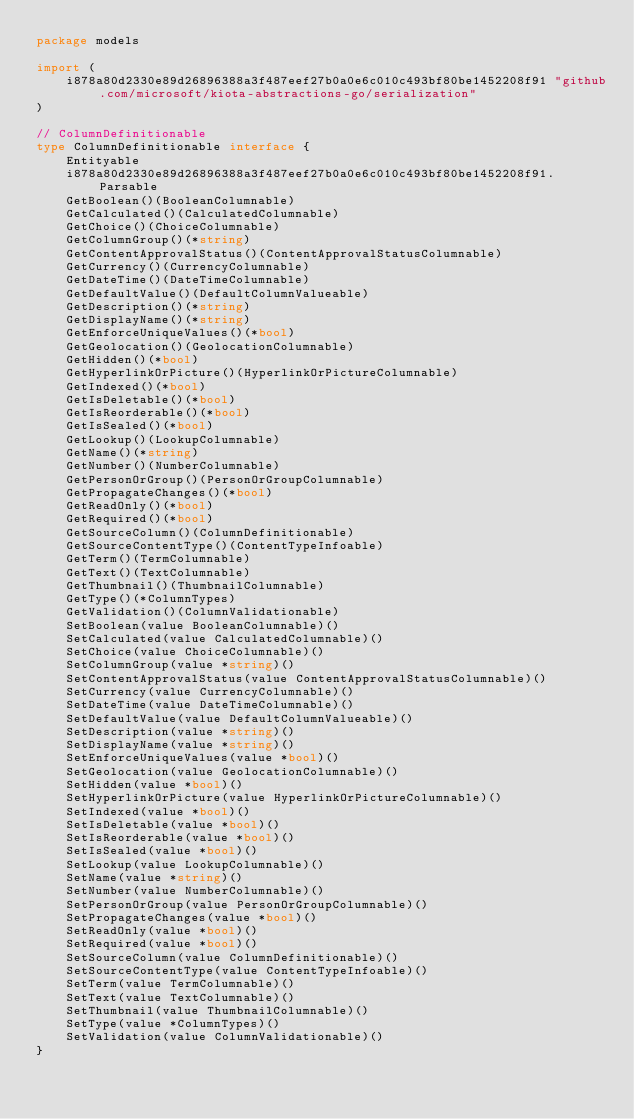Convert code to text. <code><loc_0><loc_0><loc_500><loc_500><_Go_>package models

import (
    i878a80d2330e89d26896388a3f487eef27b0a0e6c010c493bf80be1452208f91 "github.com/microsoft/kiota-abstractions-go/serialization"
)

// ColumnDefinitionable 
type ColumnDefinitionable interface {
    Entityable
    i878a80d2330e89d26896388a3f487eef27b0a0e6c010c493bf80be1452208f91.Parsable
    GetBoolean()(BooleanColumnable)
    GetCalculated()(CalculatedColumnable)
    GetChoice()(ChoiceColumnable)
    GetColumnGroup()(*string)
    GetContentApprovalStatus()(ContentApprovalStatusColumnable)
    GetCurrency()(CurrencyColumnable)
    GetDateTime()(DateTimeColumnable)
    GetDefaultValue()(DefaultColumnValueable)
    GetDescription()(*string)
    GetDisplayName()(*string)
    GetEnforceUniqueValues()(*bool)
    GetGeolocation()(GeolocationColumnable)
    GetHidden()(*bool)
    GetHyperlinkOrPicture()(HyperlinkOrPictureColumnable)
    GetIndexed()(*bool)
    GetIsDeletable()(*bool)
    GetIsReorderable()(*bool)
    GetIsSealed()(*bool)
    GetLookup()(LookupColumnable)
    GetName()(*string)
    GetNumber()(NumberColumnable)
    GetPersonOrGroup()(PersonOrGroupColumnable)
    GetPropagateChanges()(*bool)
    GetReadOnly()(*bool)
    GetRequired()(*bool)
    GetSourceColumn()(ColumnDefinitionable)
    GetSourceContentType()(ContentTypeInfoable)
    GetTerm()(TermColumnable)
    GetText()(TextColumnable)
    GetThumbnail()(ThumbnailColumnable)
    GetType()(*ColumnTypes)
    GetValidation()(ColumnValidationable)
    SetBoolean(value BooleanColumnable)()
    SetCalculated(value CalculatedColumnable)()
    SetChoice(value ChoiceColumnable)()
    SetColumnGroup(value *string)()
    SetContentApprovalStatus(value ContentApprovalStatusColumnable)()
    SetCurrency(value CurrencyColumnable)()
    SetDateTime(value DateTimeColumnable)()
    SetDefaultValue(value DefaultColumnValueable)()
    SetDescription(value *string)()
    SetDisplayName(value *string)()
    SetEnforceUniqueValues(value *bool)()
    SetGeolocation(value GeolocationColumnable)()
    SetHidden(value *bool)()
    SetHyperlinkOrPicture(value HyperlinkOrPictureColumnable)()
    SetIndexed(value *bool)()
    SetIsDeletable(value *bool)()
    SetIsReorderable(value *bool)()
    SetIsSealed(value *bool)()
    SetLookup(value LookupColumnable)()
    SetName(value *string)()
    SetNumber(value NumberColumnable)()
    SetPersonOrGroup(value PersonOrGroupColumnable)()
    SetPropagateChanges(value *bool)()
    SetReadOnly(value *bool)()
    SetRequired(value *bool)()
    SetSourceColumn(value ColumnDefinitionable)()
    SetSourceContentType(value ContentTypeInfoable)()
    SetTerm(value TermColumnable)()
    SetText(value TextColumnable)()
    SetThumbnail(value ThumbnailColumnable)()
    SetType(value *ColumnTypes)()
    SetValidation(value ColumnValidationable)()
}
</code> 